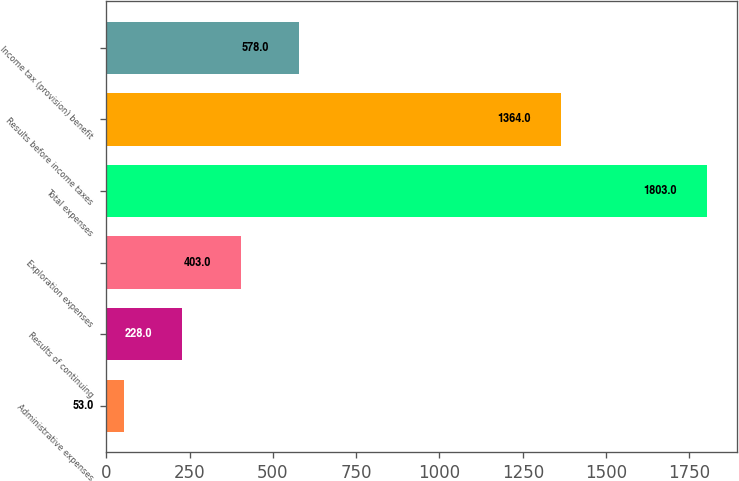<chart> <loc_0><loc_0><loc_500><loc_500><bar_chart><fcel>Administrative expenses<fcel>Results of continuing<fcel>Exploration expenses<fcel>Total expenses<fcel>Results before income taxes<fcel>Income tax (provision) benefit<nl><fcel>53<fcel>228<fcel>403<fcel>1803<fcel>1364<fcel>578<nl></chart> 